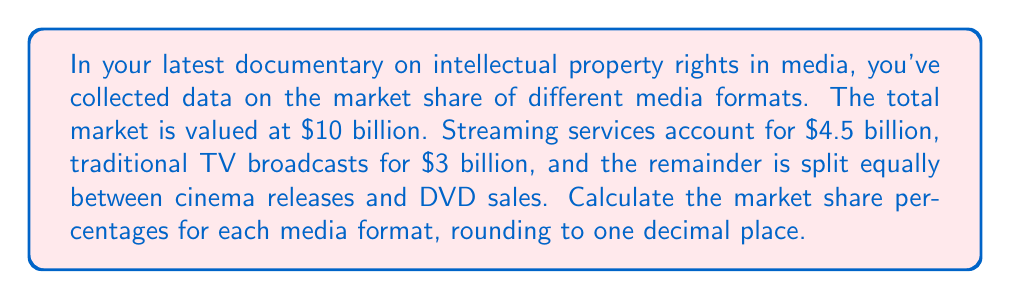Could you help me with this problem? Let's approach this step-by-step:

1) First, let's identify the given information:
   - Total market value: $10 billion
   - Streaming services: $4.5 billion
   - Traditional TV broadcasts: $3 billion
   - Remainder split equally between cinema releases and DVD sales

2) Calculate the remainder for cinema releases and DVD sales:
   $10 billion - $4.5 billion - $3 billion = $2.5 billion

3) Since this remainder is split equally, each gets:
   $2.5 billion ÷ 2 = $1.25 billion

4) Now, let's calculate the market share percentages:

   For streaming services:
   $$\frac{4.5}{10} \times 100 = 45\%$$

   For traditional TV broadcasts:
   $$\frac{3}{10} \times 100 = 30\%$$

   For cinema releases:
   $$\frac{1.25}{10} \times 100 = 12.5\%$$

   For DVD sales:
   $$\frac{1.25}{10} \times 100 = 12.5\%$$

5) Rounding to one decimal place:
   - Streaming services: 45.0%
   - Traditional TV broadcasts: 30.0%
   - Cinema releases: 12.5%
   - DVD sales: 12.5%
Answer: 45.0%, 30.0%, 12.5%, 12.5% 